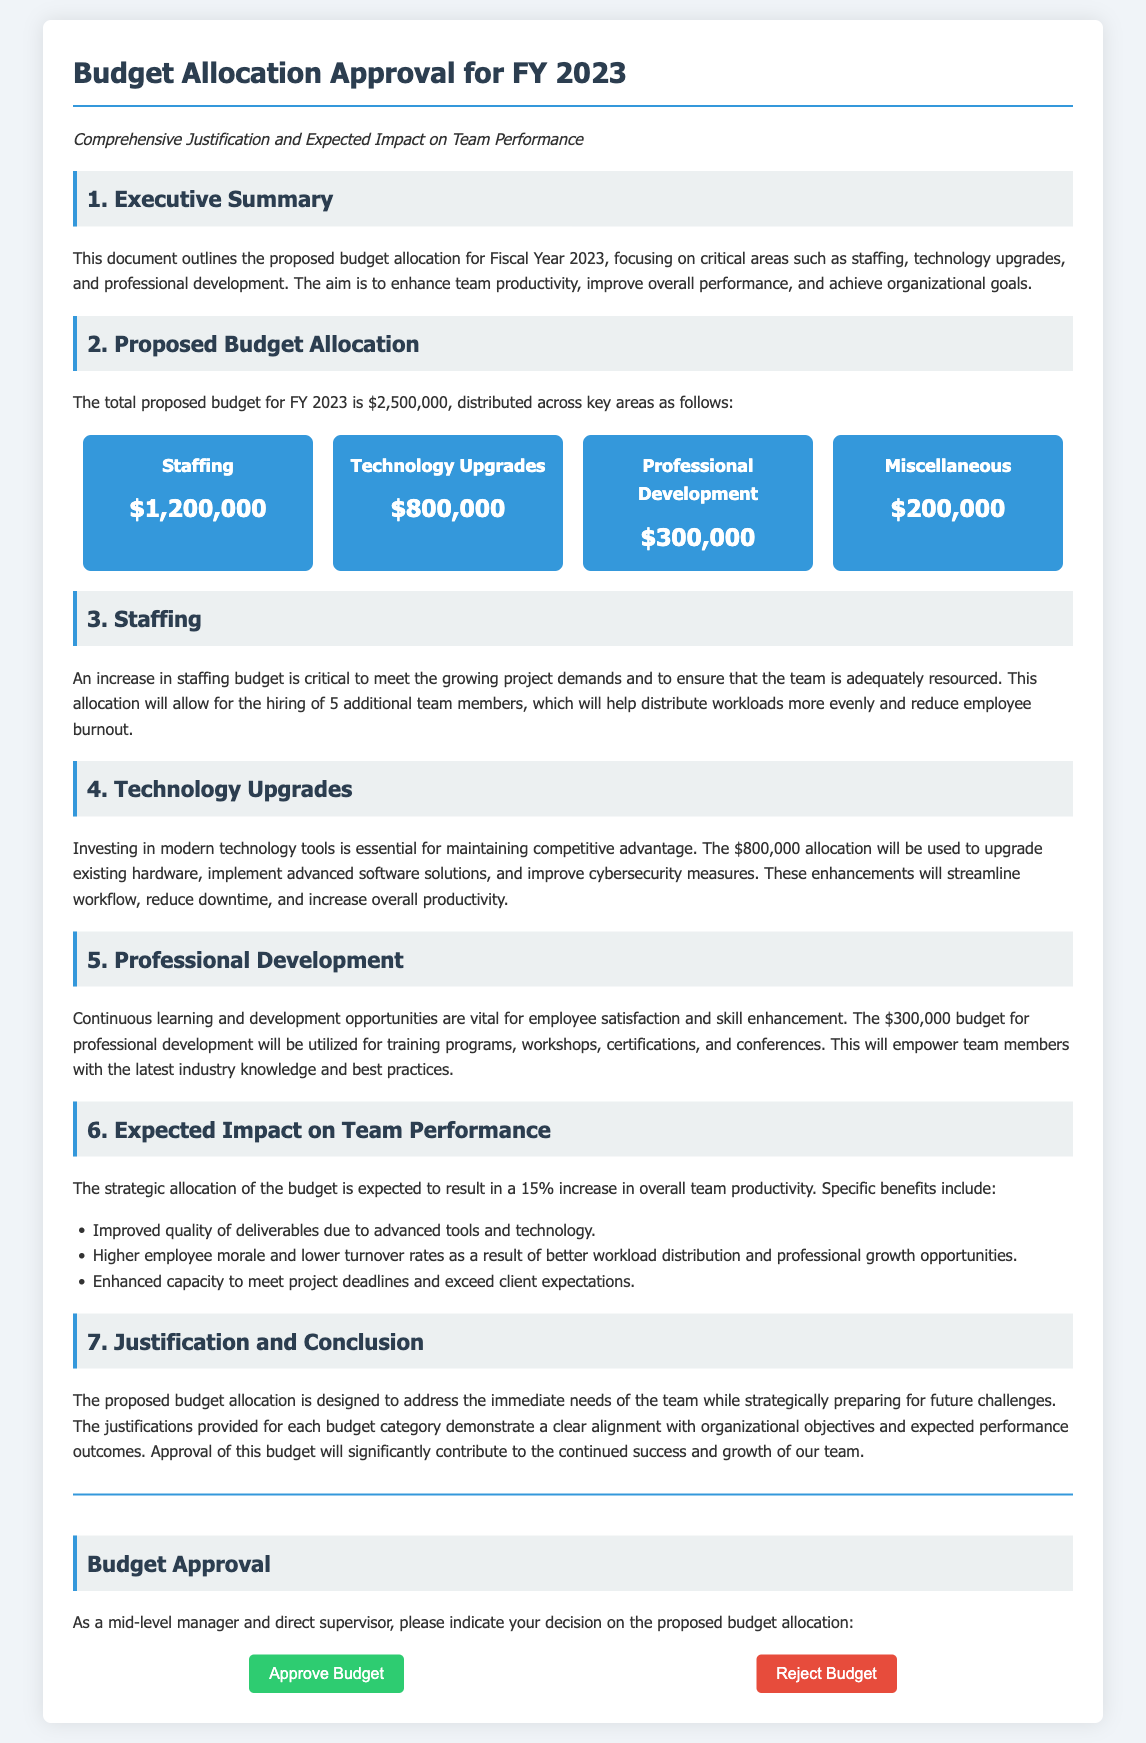What is the total proposed budget for FY 2023? The total proposed budget is explicitly stated in the document as $2,500,000.
Answer: $2,500,000 How much is allocated for staffing? The document specifies that the staffing budget allocation is $1,200,000.
Answer: $1,200,000 What is the expected increase in overall team productivity? The document mentions a 15% increase in overall team productivity as a result of the budget allocation.
Answer: 15% How many additional team members will be hired? The document indicates that 5 additional team members will be hired to meet project demands.
Answer: 5 What is the budget for professional development? The budget allocation for professional development is clearly stated as $300,000 in the document.
Answer: $300,000 What is the purpose of the technology upgrades? The document states that the purpose is to maintain competitive advantage through modernizing technology.
Answer: Maintain competitive advantage Why is the staffing budget increase critical? The document explains that it is critical to meet growing project demands and reduce employee burnout.
Answer: Meet growing project demands What will the professional development budget be used for? The document notes that it will be used for training programs, workshops, certifications, and conferences.
Answer: Training programs, workshops, certifications, and conferences What section summarizes the expected impact on team performance? The expected impact on team performance is summarized in Section 6 of the document.
Answer: Section 6 